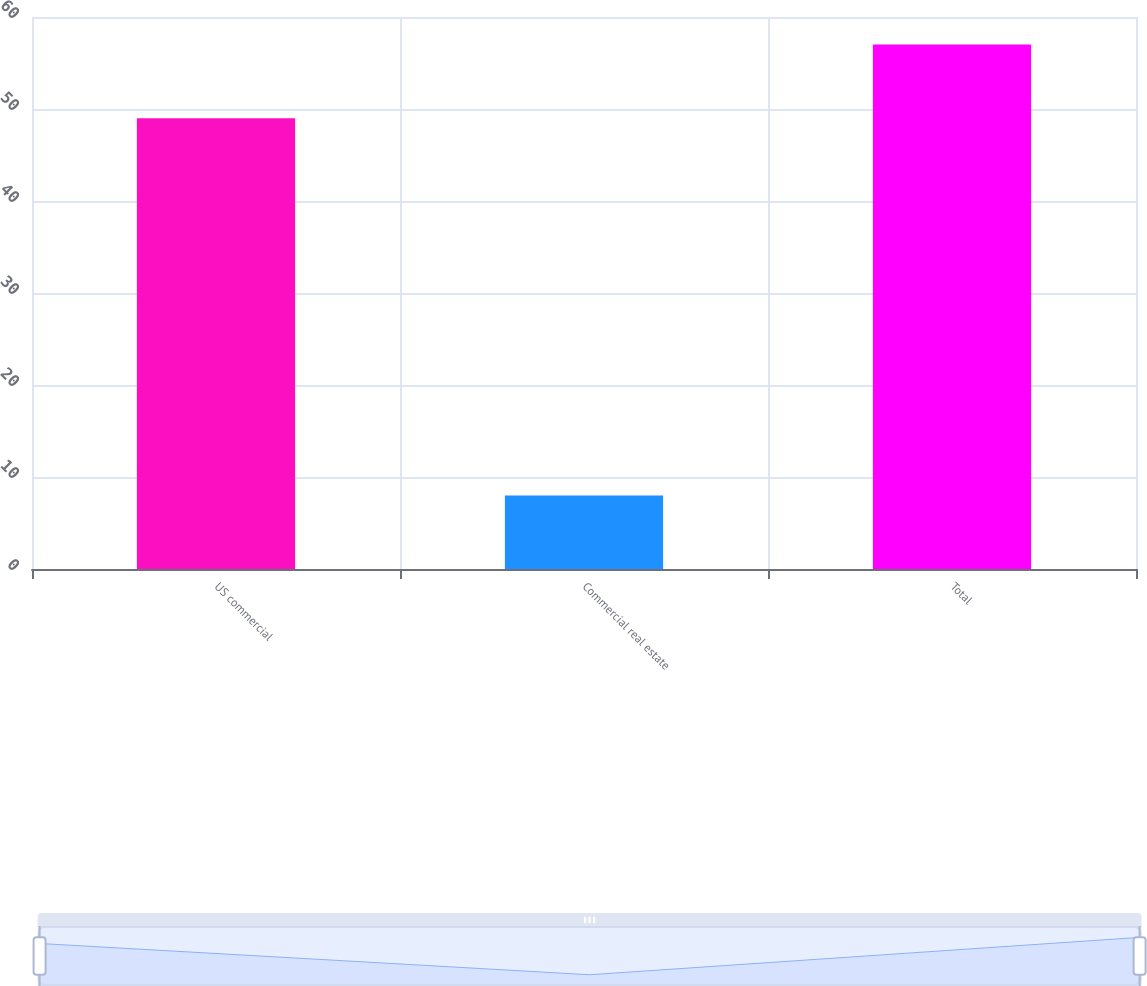<chart> <loc_0><loc_0><loc_500><loc_500><bar_chart><fcel>US commercial<fcel>Commercial real estate<fcel>Total<nl><fcel>49<fcel>8<fcel>57<nl></chart> 